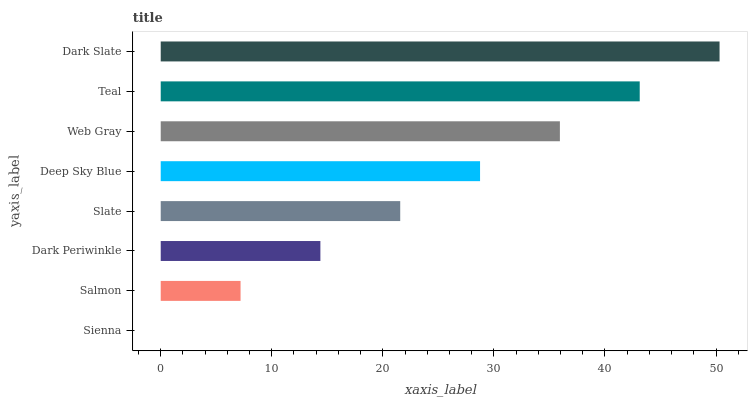Is Sienna the minimum?
Answer yes or no. Yes. Is Dark Slate the maximum?
Answer yes or no. Yes. Is Salmon the minimum?
Answer yes or no. No. Is Salmon the maximum?
Answer yes or no. No. Is Salmon greater than Sienna?
Answer yes or no. Yes. Is Sienna less than Salmon?
Answer yes or no. Yes. Is Sienna greater than Salmon?
Answer yes or no. No. Is Salmon less than Sienna?
Answer yes or no. No. Is Deep Sky Blue the high median?
Answer yes or no. Yes. Is Slate the low median?
Answer yes or no. Yes. Is Teal the high median?
Answer yes or no. No. Is Salmon the low median?
Answer yes or no. No. 